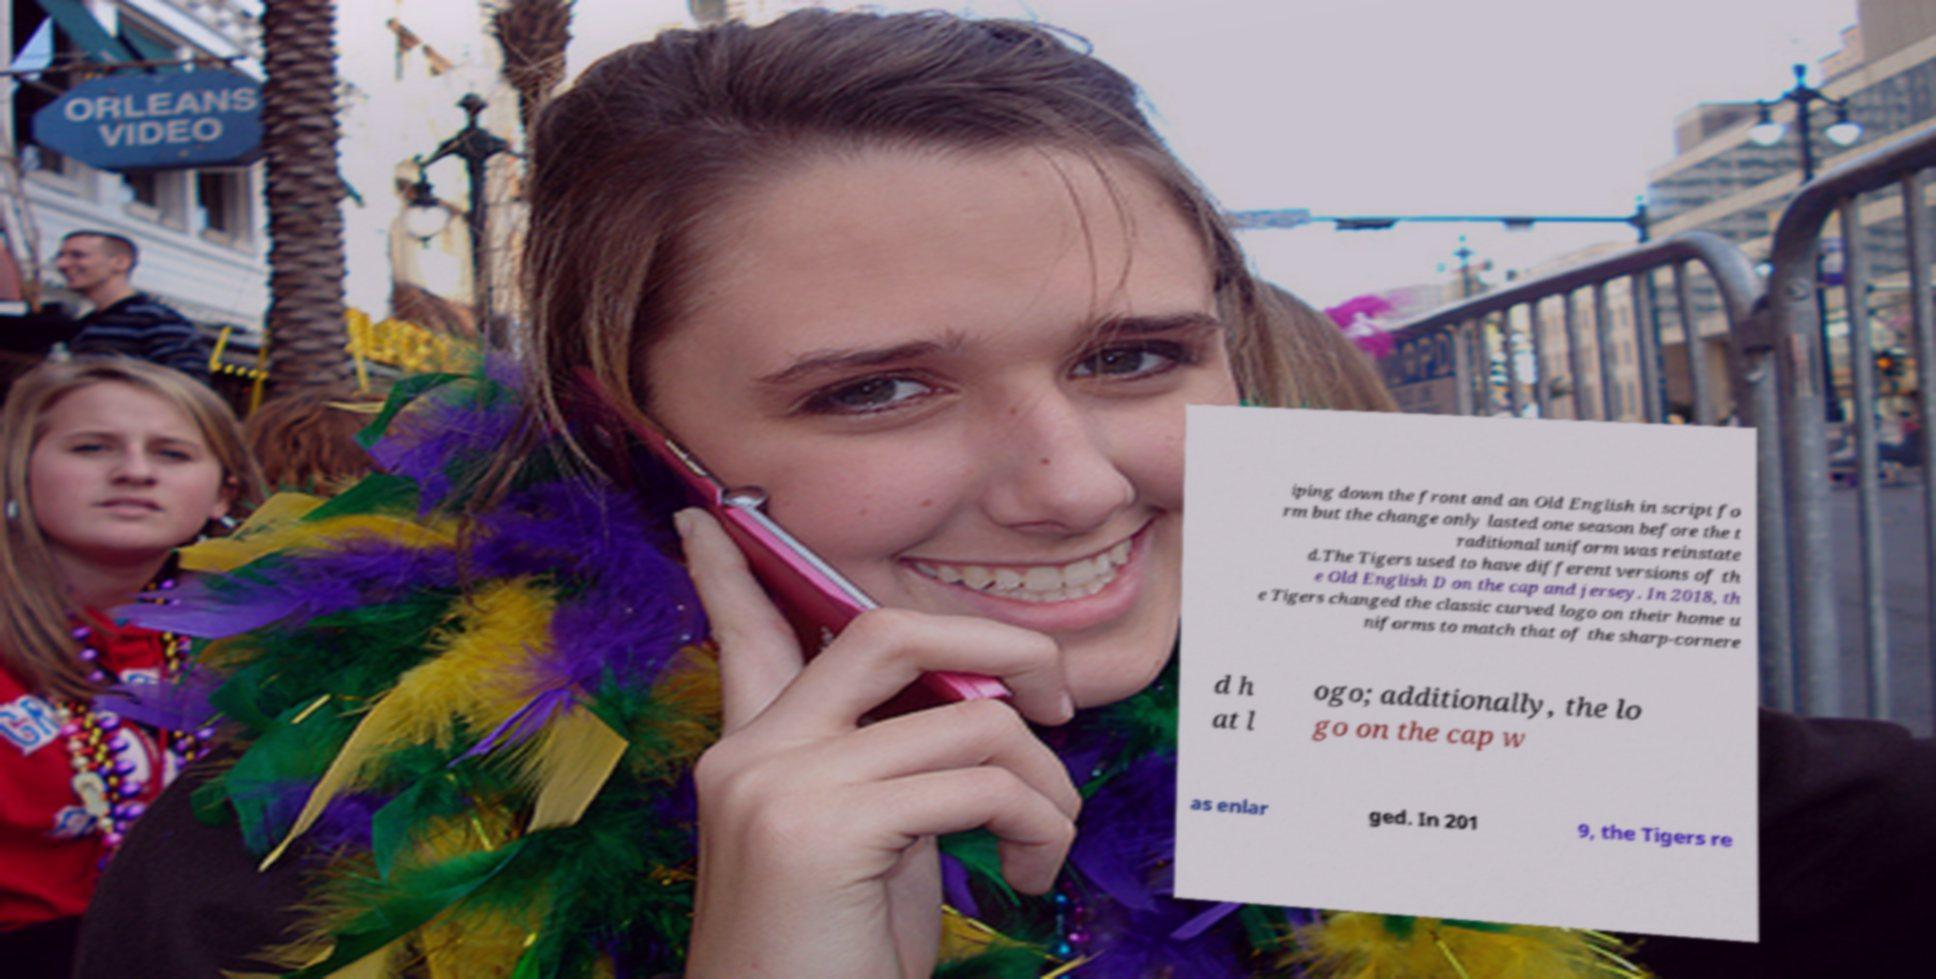Can you read and provide the text displayed in the image?This photo seems to have some interesting text. Can you extract and type it out for me? iping down the front and an Old English in script fo rm but the change only lasted one season before the t raditional uniform was reinstate d.The Tigers used to have different versions of th e Old English D on the cap and jersey. In 2018, th e Tigers changed the classic curved logo on their home u niforms to match that of the sharp-cornere d h at l ogo; additionally, the lo go on the cap w as enlar ged. In 201 9, the Tigers re 